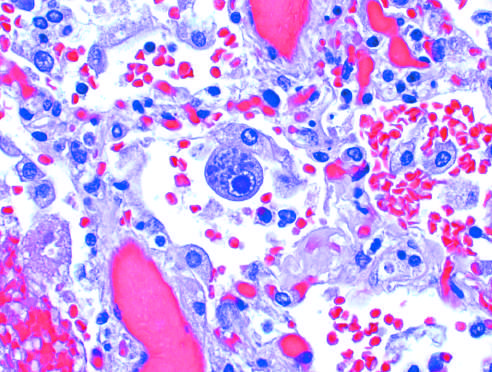what are seen in an enlarged cell?
Answer the question using a single word or phrase. A distinct nuclear inclusion and multiple cytoplasmic inclusions 